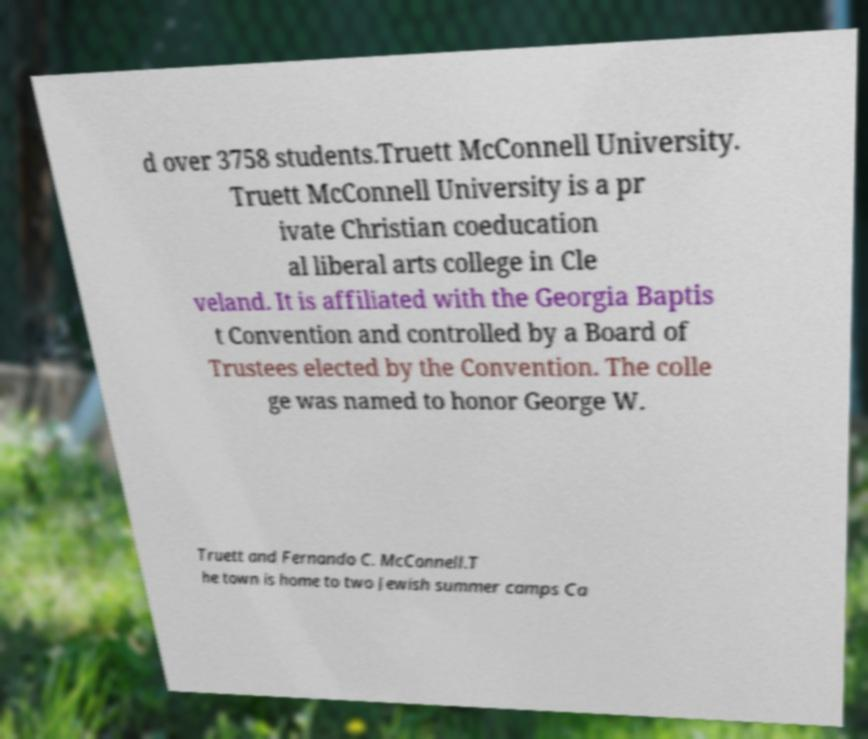Can you accurately transcribe the text from the provided image for me? d over 3758 students.Truett McConnell University. Truett McConnell University is a pr ivate Christian coeducation al liberal arts college in Cle veland. It is affiliated with the Georgia Baptis t Convention and controlled by a Board of Trustees elected by the Convention. The colle ge was named to honor George W. Truett and Fernando C. McConnell.T he town is home to two Jewish summer camps Ca 